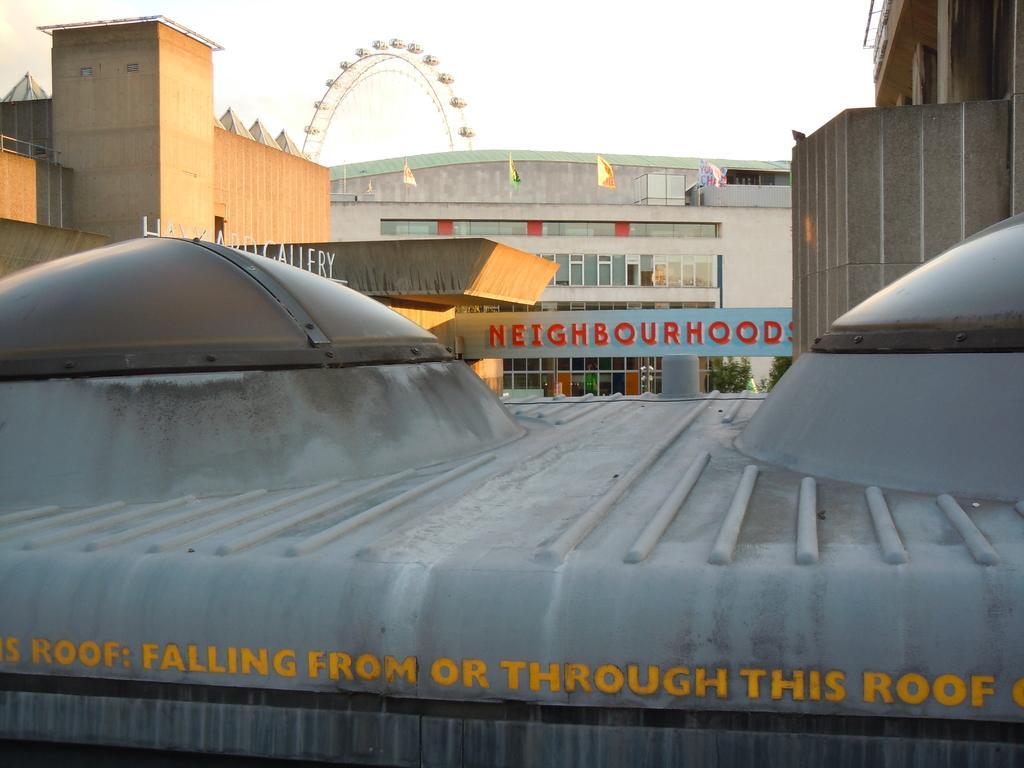How would you summarize this image in a sentence or two? In the foreground, I can see a metal object and a text. In the background, I can see buildings, houseplants, flags, metal objects and the sky. This image is taken, maybe during a day. 